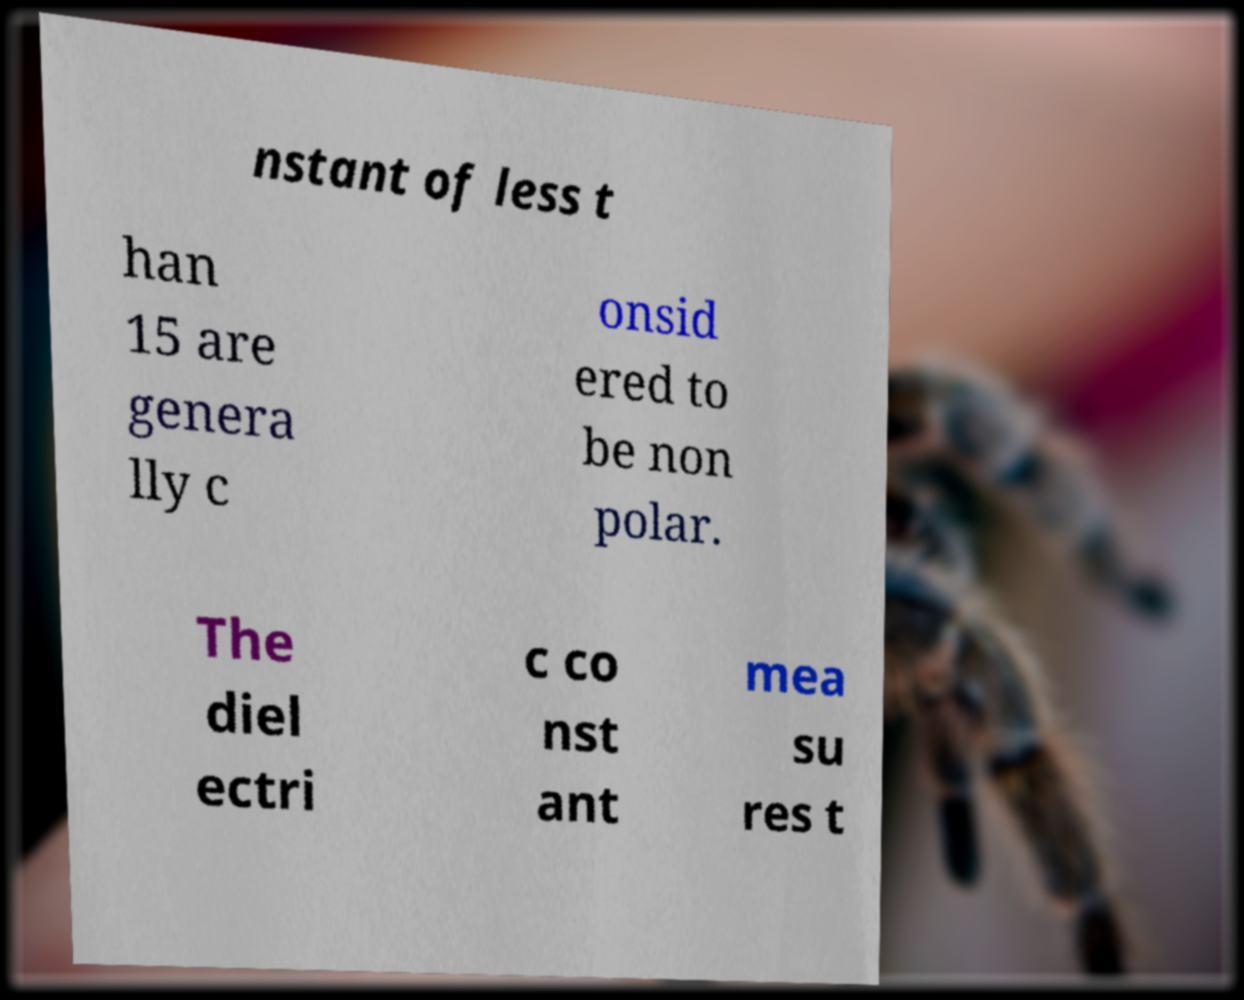There's text embedded in this image that I need extracted. Can you transcribe it verbatim? nstant of less t han 15 are genera lly c onsid ered to be non polar. The diel ectri c co nst ant mea su res t 